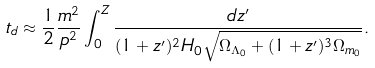Convert formula to latex. <formula><loc_0><loc_0><loc_500><loc_500>t _ { d } \approx \frac { 1 } { 2 } \frac { m ^ { 2 } } { p ^ { 2 } } \int _ { 0 } ^ { Z } \frac { d z ^ { \prime } } { ( 1 + z ^ { \prime } ) ^ { 2 } H _ { 0 } \sqrt { \Omega _ { \Lambda _ { 0 } } + ( 1 + z ^ { \prime } ) ^ { 3 } \Omega _ { m _ { 0 } } } } .</formula> 